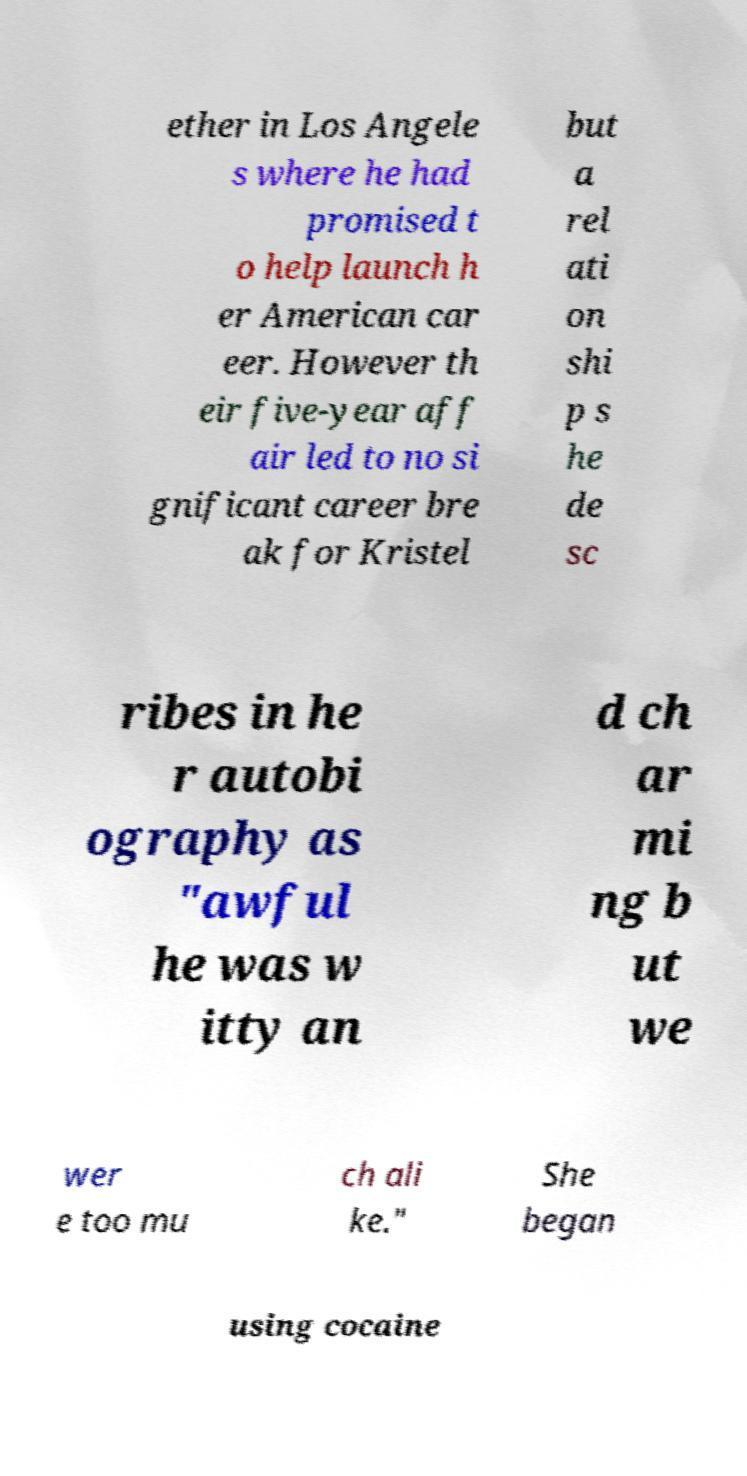Can you accurately transcribe the text from the provided image for me? ether in Los Angele s where he had promised t o help launch h er American car eer. However th eir five-year aff air led to no si gnificant career bre ak for Kristel but a rel ati on shi p s he de sc ribes in he r autobi ography as "awful he was w itty an d ch ar mi ng b ut we wer e too mu ch ali ke." She began using cocaine 